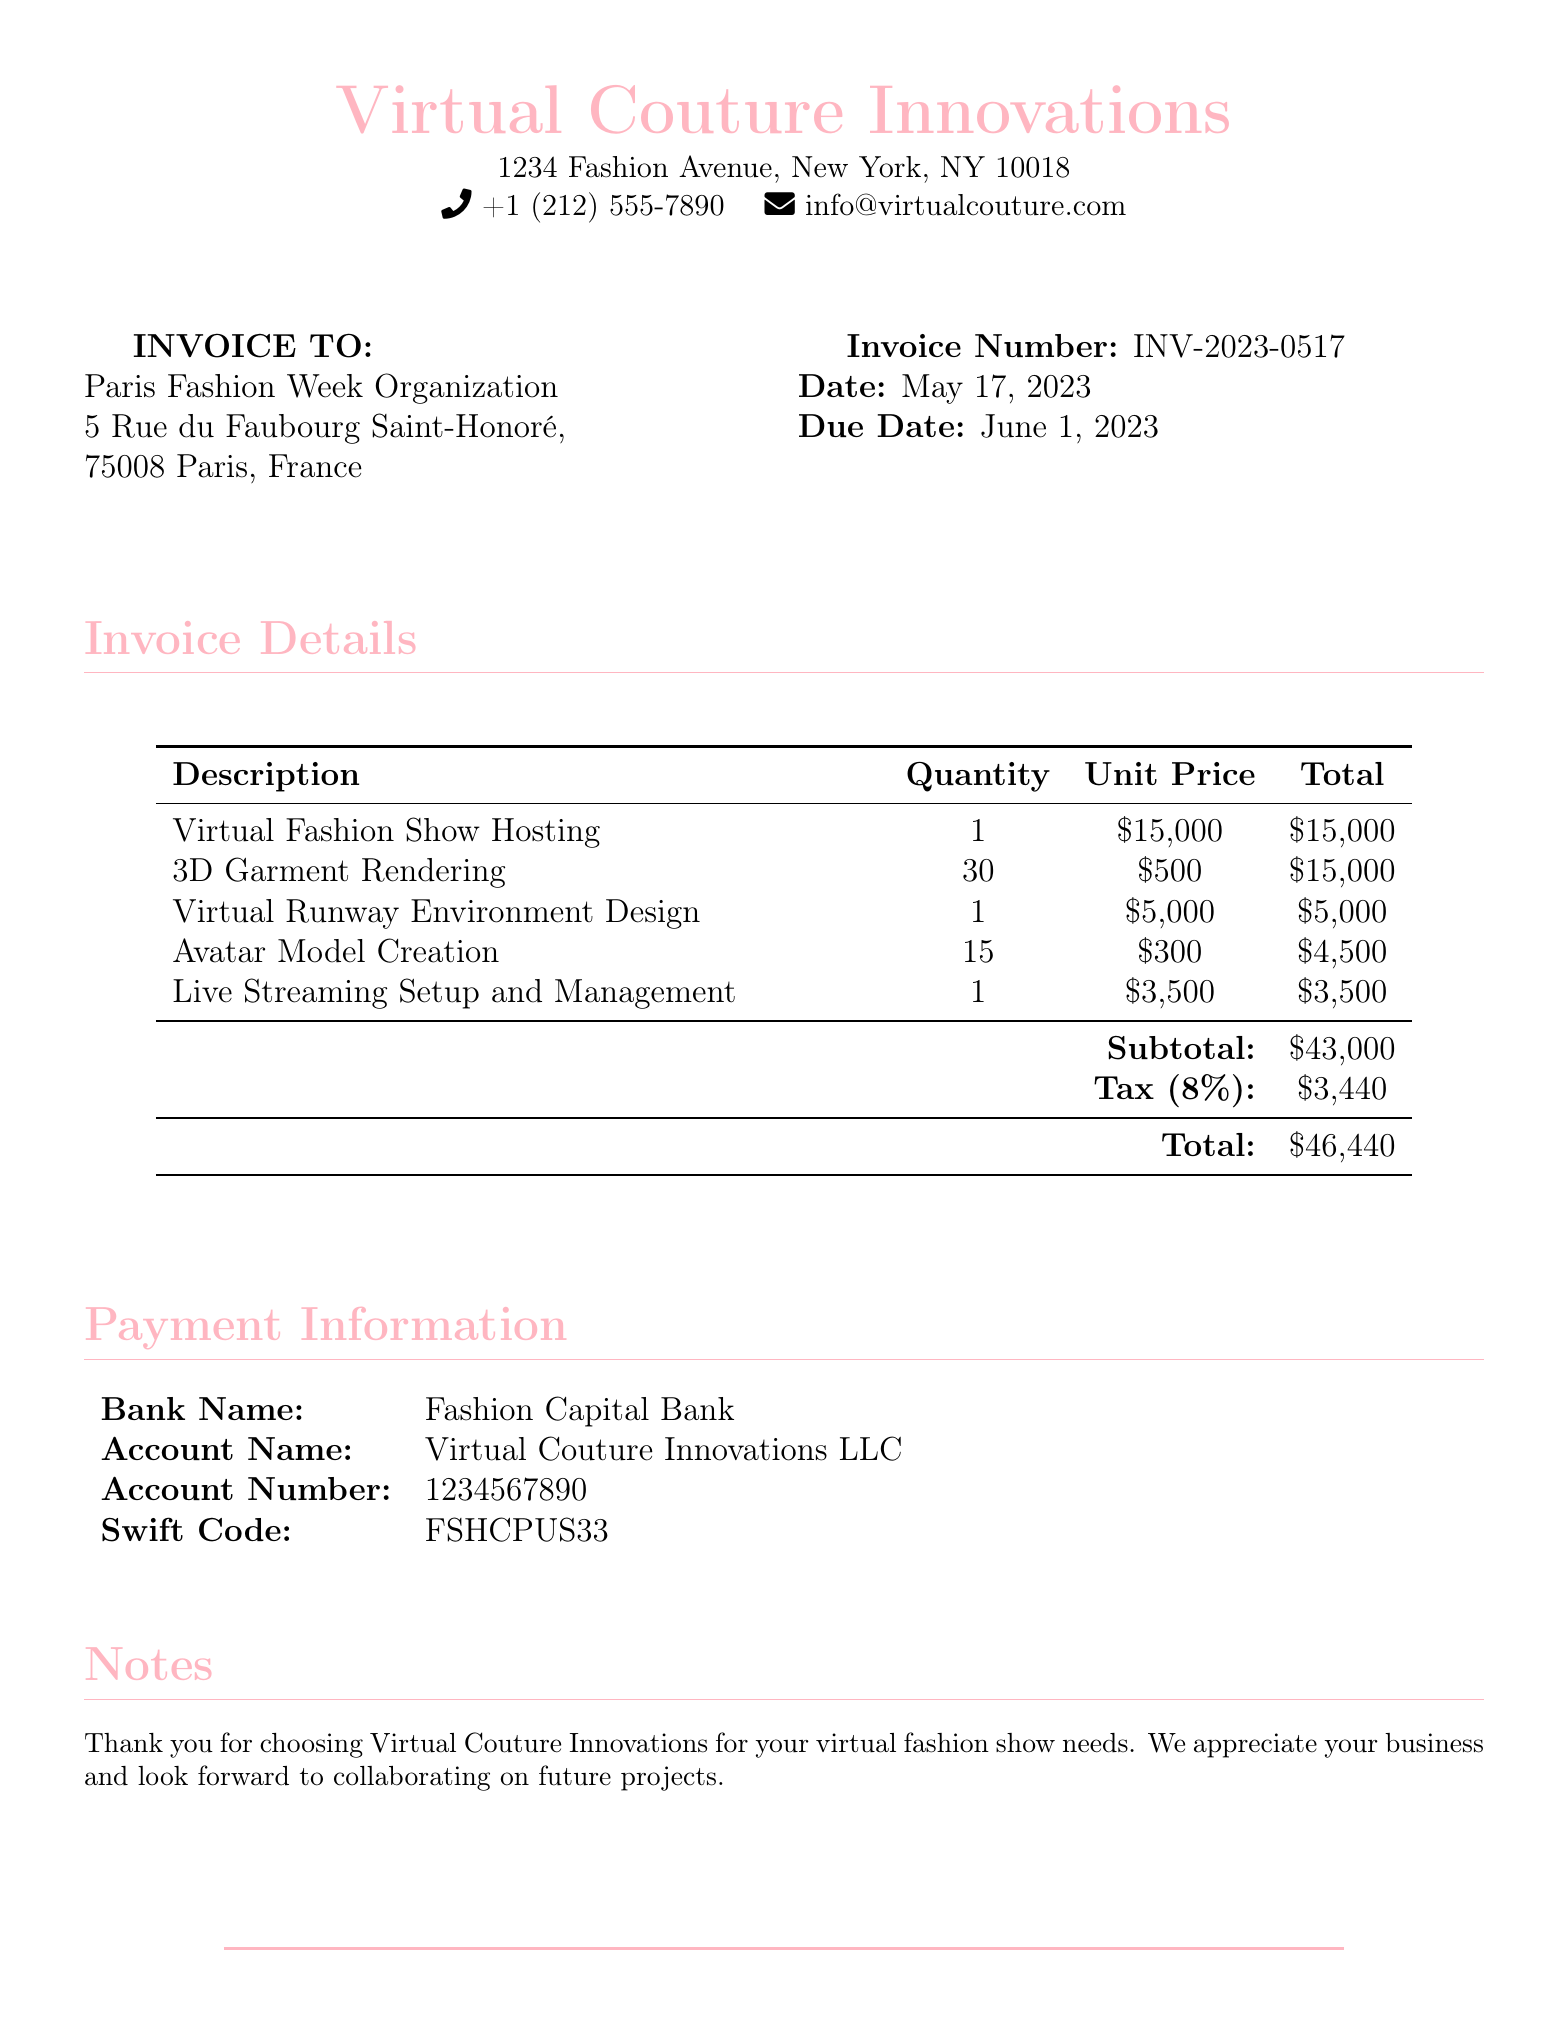what is the total amount due? The total amount due is listed at the bottom of the invoice, which is the final sum after tax.
Answer: $46,440 what is the invoice number? The invoice number is specified in the document for reference.
Answer: INV-2023-0517 what is the date of the invoice? The date of the invoice indicates when it was issued and is clearly stated in the document.
Answer: May 17, 2023 how much is charged for the Virtual Fashion Show Hosting? The charge for Virtual Fashion Show Hosting is detailed under the itemized expenses.
Answer: $15,000 what is the tax percentage applied to the subtotal? The document states the tax percentage that was applied, found in the tax line.
Answer: 8% how many avatar models were created? The quantity of avatar models created is mentioned in the itemized section of the invoice.
Answer: 15 what is the subtotal before tax? The subtotal is calculated by summing all items before tax is applied.
Answer: $43,000 which bank is provided for the payment information? The name of the bank for payment is located in the payment information section.
Answer: Fashion Capital Bank what is the due date for the invoice? The due date is indicated in the document for payment reference.
Answer: June 1, 2023 how much is the total charge for 3D garment rendering? The total amount for 3D garment rendering can be found in the itemized list.
Answer: $15,000 